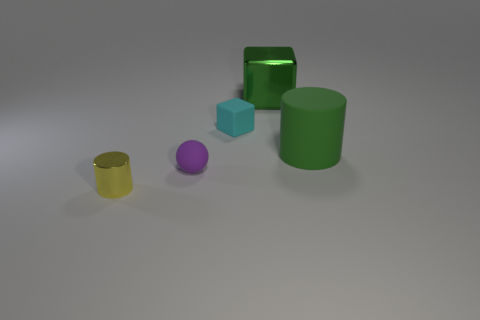What is the small cylinder made of?
Your response must be concise. Metal. Is the material of the large green cylinder the same as the big green block?
Give a very brief answer. No. Do the metallic thing behind the shiny cylinder and the large rubber object have the same color?
Make the answer very short. Yes. There is a object that is right of the cyan rubber object and left of the green cylinder; what is its material?
Give a very brief answer. Metal. Are there more things than brown metallic things?
Make the answer very short. Yes. What color is the thing on the right side of the green thing that is to the left of the cylinder that is right of the green metallic object?
Offer a very short reply. Green. Do the cylinder behind the tiny yellow cylinder and the cyan block have the same material?
Provide a succinct answer. Yes. Are there any metallic objects that have the same color as the big cylinder?
Your answer should be compact. Yes. Are any large cyan metallic things visible?
Provide a short and direct response. No. Is the size of the metallic thing that is to the right of the yellow metal thing the same as the large green matte object?
Your response must be concise. Yes. 